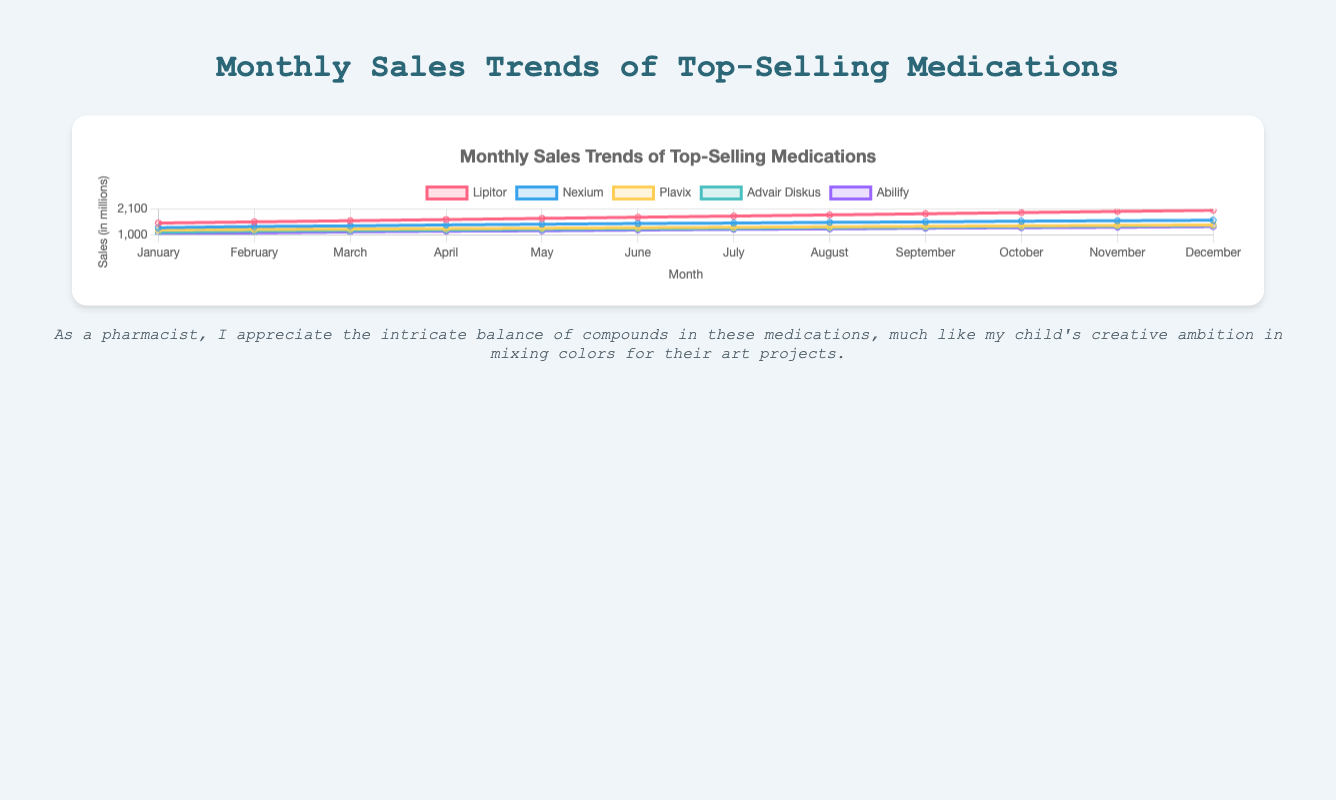Which medication had the highest sales in December? In December, we look at the sales data for each medication to determine the highest sales figure. Lipitor had the highest sales with 2050 units.
Answer: Lipitor What is the difference in sales between Nexium and Plavix in July? For July, Nexium's sales are 1500 units, and Plavix's sales are 1320 units. The difference is 1500 - 1320 = 180 units.
Answer: 180 On average, how much did Lipitor's monthly sales increase from January to June? First, find Lipitor's sales from January to June: 1500, 1550, 1600, 1650, 1700, 1750. The total increase is (1750 - 1500) = 250 units over 5 months. The average monthly increase is 250 / 5 = 50 units.
Answer: 50 Which month shows the highest sales for the combination of medications treating Cardiovascular Disease (Lipitor and Plavix)? Sum the sales of Lipitor and Plavix for each month to find the highest total. December has Lipitor (2050) + Plavix (1420) = 3470 units, which is the highest combined sales.
Answer: December In November, which ailment category had the lowest total sales, and what was the sales figure? Summarize sales by ailment for November. Cardiovascular Disease: Lipitor (2000) + Plavix (1400) = 3400. Gastroesophageal Reflux Disease: Nexium (1600). Asthma & COPD: Advair Diskus (1370). Mental Health: Abilify (1320). Mental Health has the lowest sales with 1320 units.
Answer: Mental Health, 1320 Compare the trend between Lipitor and Advair Diskus from January to December. Observe the slope and direction of the lines for both medications. Lipitor shows a consistent and significant increase in sales from 1500 in January to 2050 in December, while Advair Diskus shows a smaller, steady increase from 1100 in January to 1400 in December.
Answer: Lipitor has a steeper increase than Advair Diskus What is the total sales for Abilify across all months? Sum Abilify's monthly sales: 1050 + 1080 + 1120 + 1150 + 1170 + 1200 + 1230 + 1250 + 1280 + 1300 + 1320 + 1350 = 14500 units.
Answer: 14500 How much higher were the sales for Nexium in August compared to January? Nexium's sales in August are 1530 units, and in January, they were 1300 units. The difference is 1530 - 1300 = 230 units.
Answer: 230 Which medication had the smallest increase in sales from February to March? Calculate the sales increase for each medication from February to March. Lipitor: 1600 - 1550 = 50. Nexium: 1380 - 1350 = 30. Plavix: 1240 - 1220 = 20. Advair Diskus: 1180 - 1150 = 30. Abilify: 1120 - 1080 = 40. Plavix had the smallest increase with 20 units.
Answer: Plavix What were the combined sales for medications treating Gastroesophageal Reflux Disease and Asthma & COPD in June? Sum Nexium and Advair Diskus sales in June. Nexium: 1480, Advair Diskus: 1250. Combined sales: 1480 + 1250 = 2730 units.
Answer: 2730 